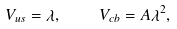<formula> <loc_0><loc_0><loc_500><loc_500>V _ { u s } = \lambda , \quad V _ { c b } = A \lambda ^ { 2 } ,</formula> 